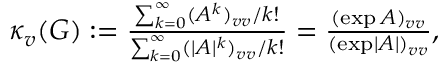<formula> <loc_0><loc_0><loc_500><loc_500>\begin{array} { r } { \kappa _ { v } ( G ) \colon = \frac { \sum _ { k = 0 } ^ { \infty } ( A ^ { k } ) _ { v v } / k ! } { \sum _ { k = 0 } ^ { \infty } ( | A | ^ { k } ) _ { v v } / k ! } = \frac { ( \exp A ) _ { v v } } { ( \exp | A | ) _ { v v } } , } \end{array}</formula> 